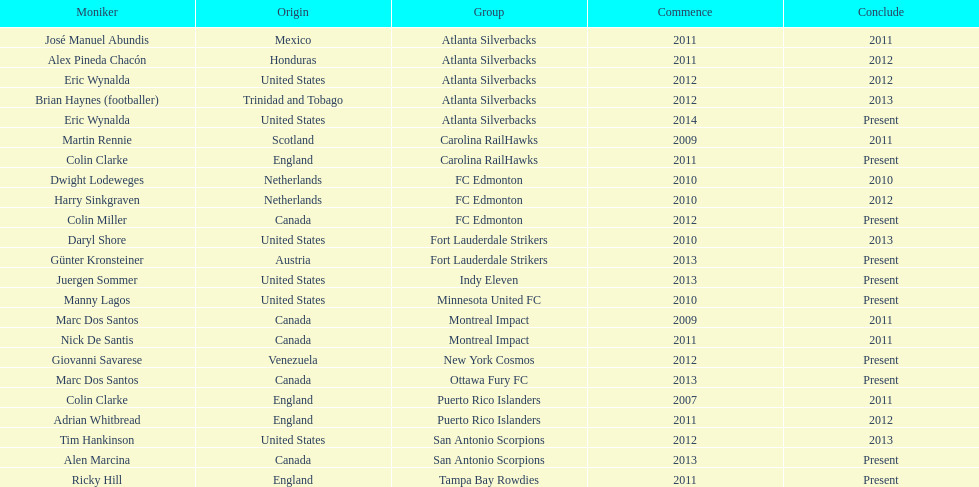Marc dos santos started as coach the same year as what other coach? Martin Rennie. 